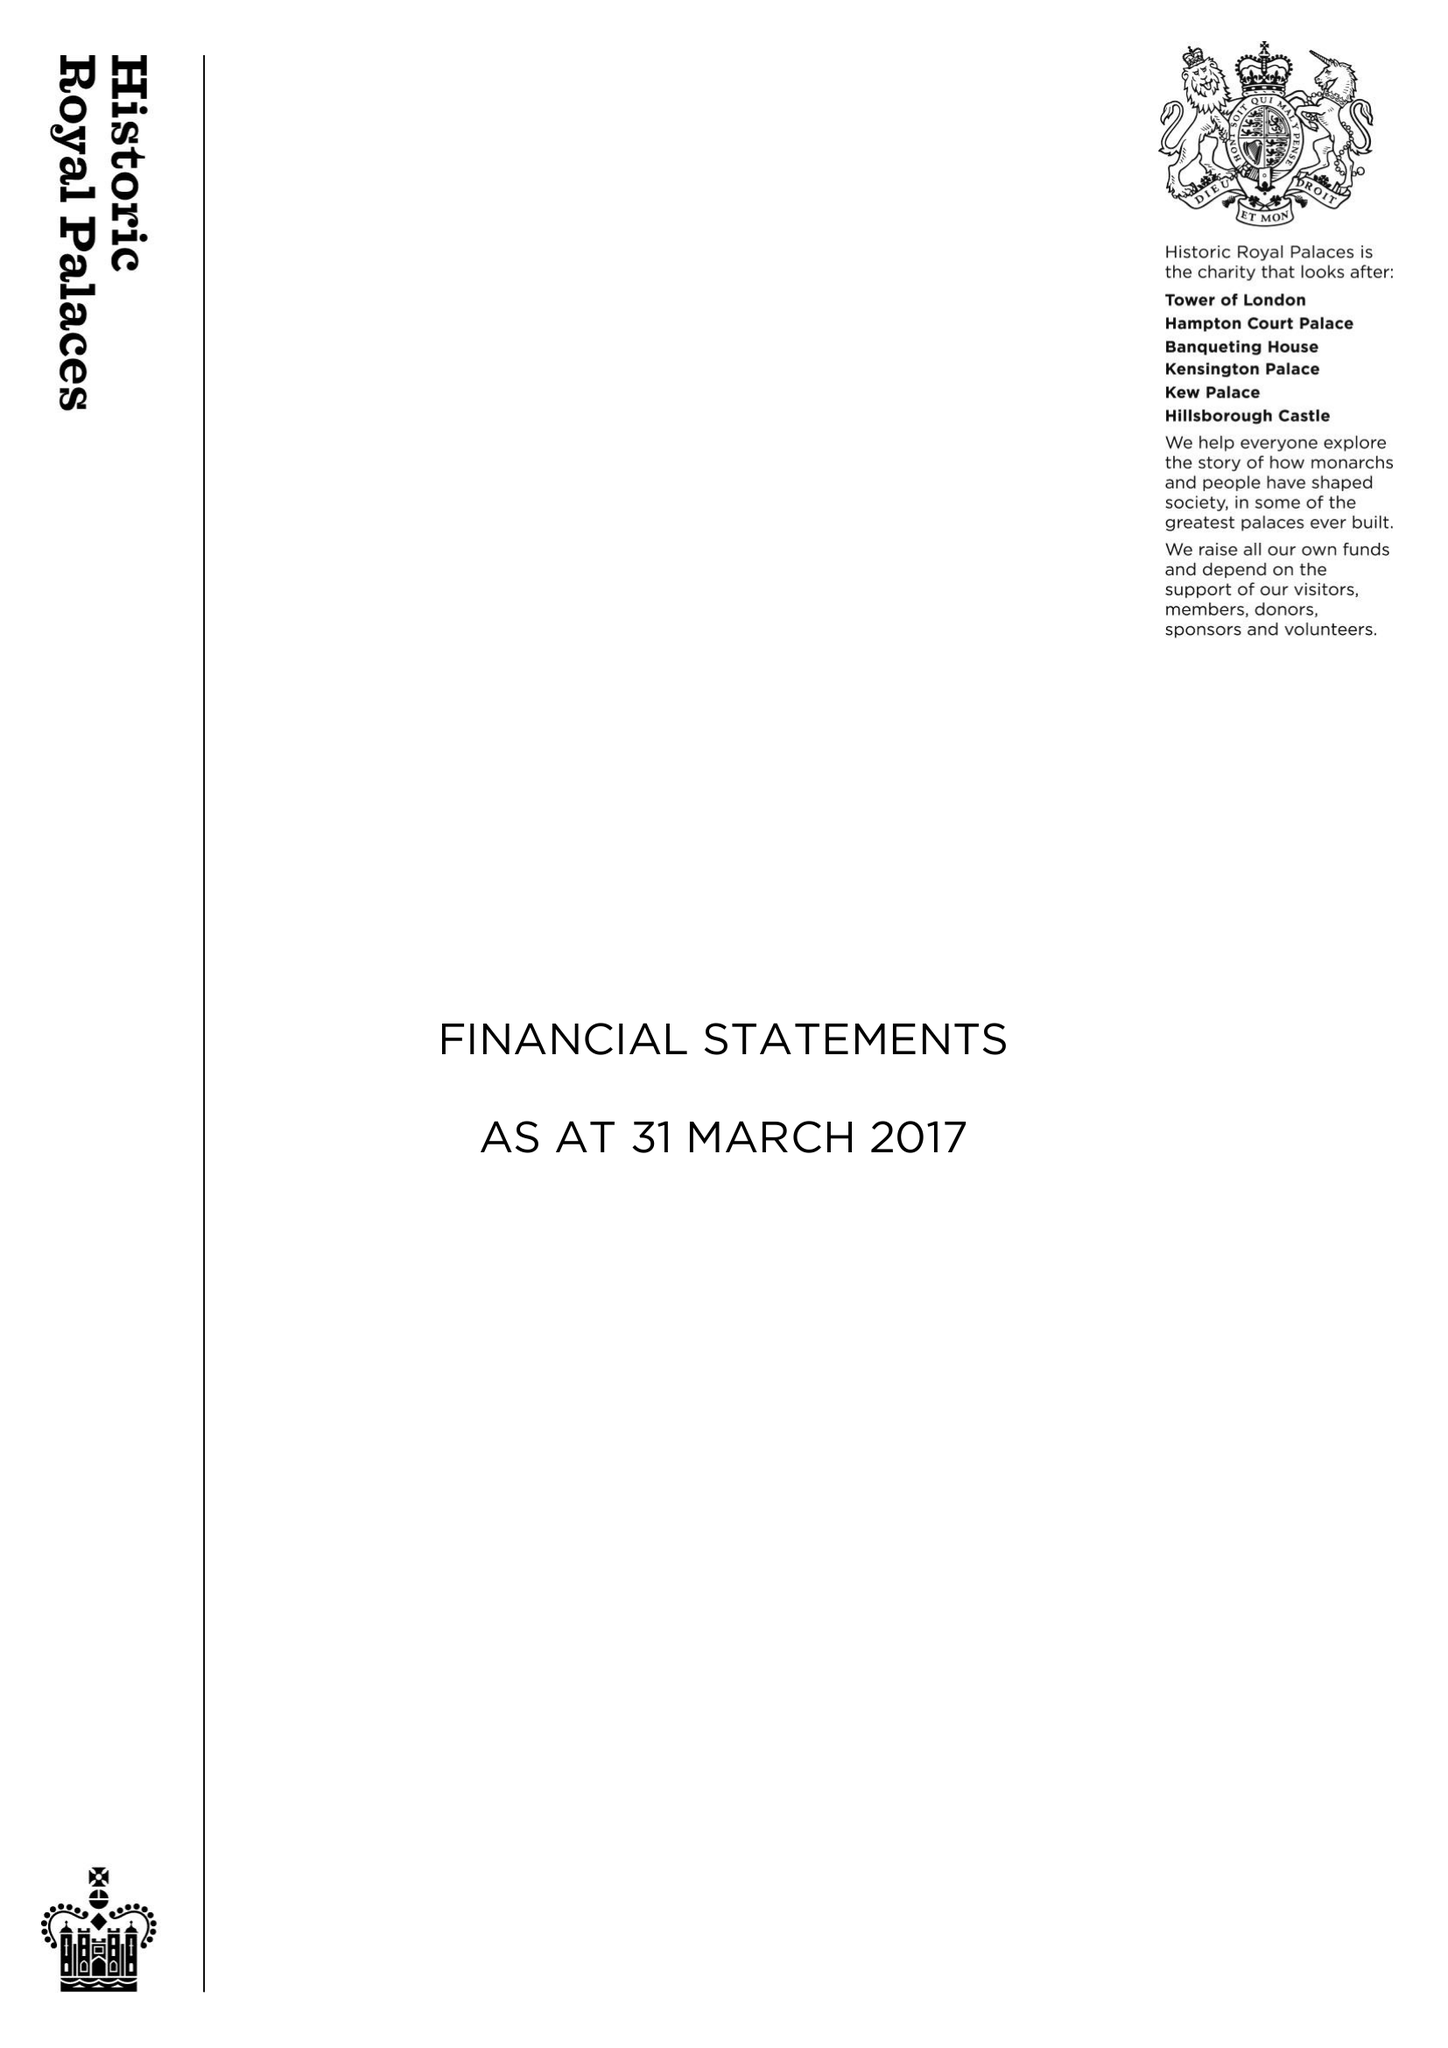What is the value for the charity_name?
Answer the question using a single word or phrase. Historic Royal Palaces 